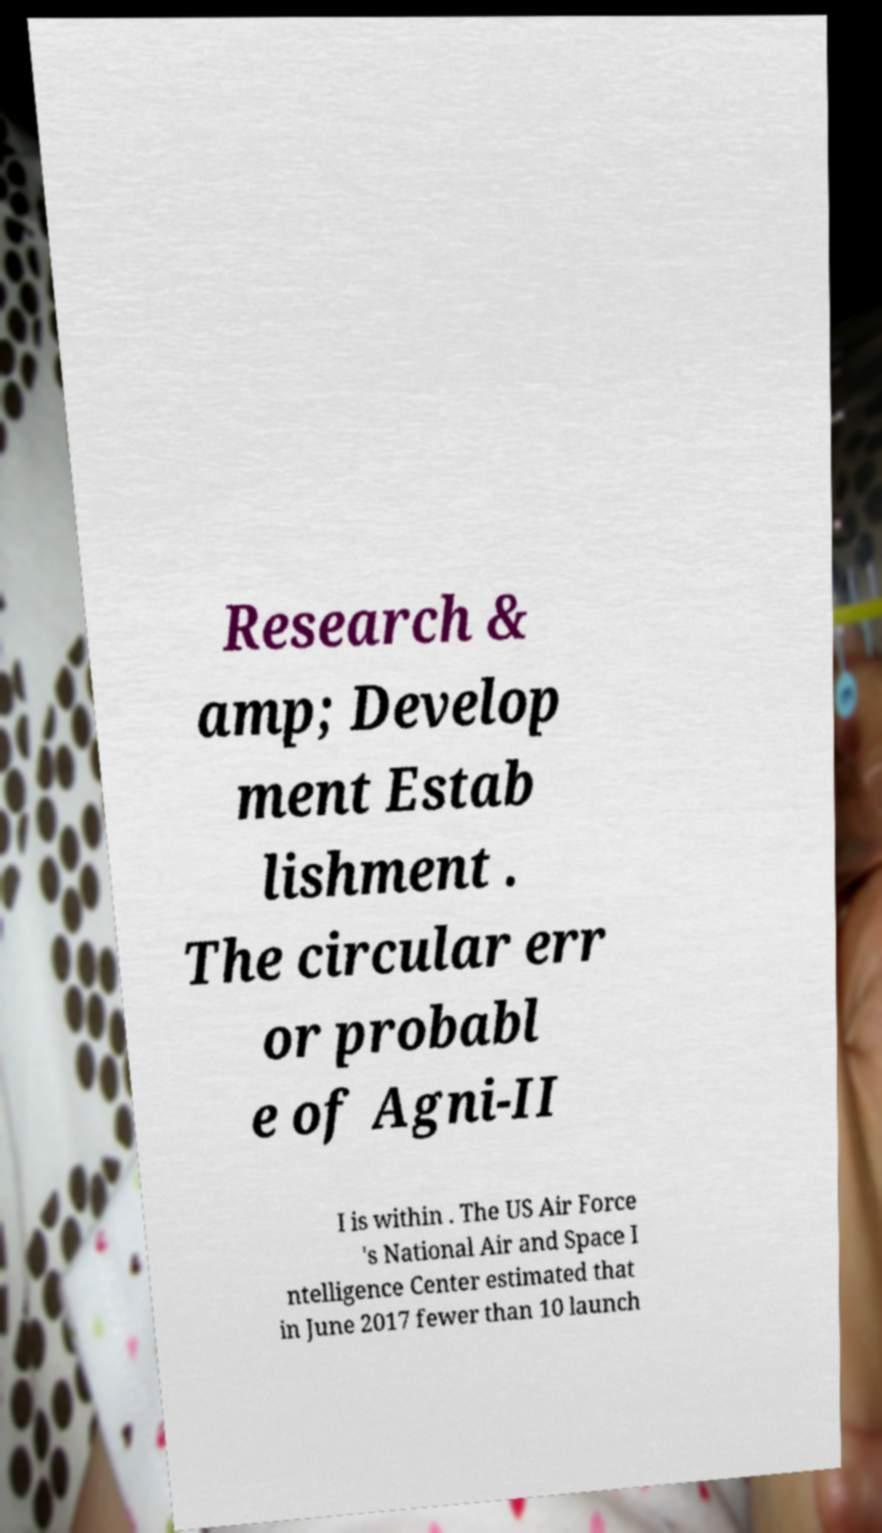Can you read and provide the text displayed in the image?This photo seems to have some interesting text. Can you extract and type it out for me? Research & amp; Develop ment Estab lishment . The circular err or probabl e of Agni-II I is within . The US Air Force 's National Air and Space I ntelligence Center estimated that in June 2017 fewer than 10 launch 